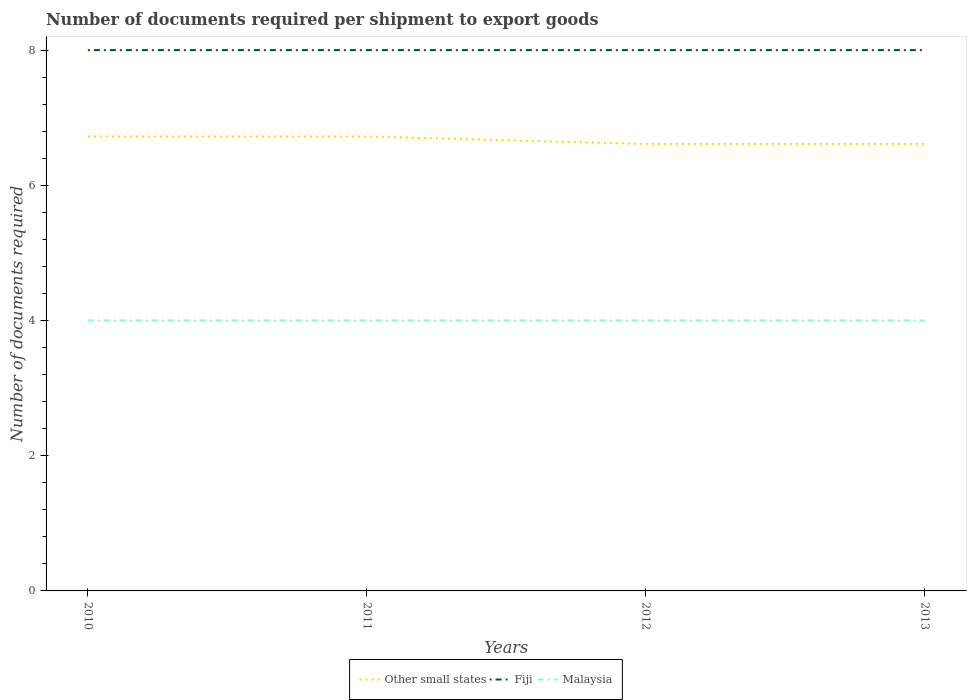Does the line corresponding to Other small states intersect with the line corresponding to Malaysia?
Keep it short and to the point. No. Is the number of lines equal to the number of legend labels?
Keep it short and to the point. Yes. Across all years, what is the maximum number of documents required per shipment to export goods in Malaysia?
Offer a very short reply. 4. What is the total number of documents required per shipment to export goods in Other small states in the graph?
Your answer should be very brief. 0.11. What is the difference between the highest and the second highest number of documents required per shipment to export goods in Malaysia?
Offer a very short reply. 0. What is the difference between the highest and the lowest number of documents required per shipment to export goods in Other small states?
Give a very brief answer. 2. Is the number of documents required per shipment to export goods in Malaysia strictly greater than the number of documents required per shipment to export goods in Other small states over the years?
Provide a succinct answer. Yes. How many lines are there?
Provide a short and direct response. 3. What is the difference between two consecutive major ticks on the Y-axis?
Offer a very short reply. 2. Does the graph contain any zero values?
Offer a very short reply. No. Does the graph contain grids?
Ensure brevity in your answer.  No. How many legend labels are there?
Your response must be concise. 3. How are the legend labels stacked?
Offer a very short reply. Horizontal. What is the title of the graph?
Ensure brevity in your answer.  Number of documents required per shipment to export goods. Does "Kyrgyz Republic" appear as one of the legend labels in the graph?
Your answer should be very brief. No. What is the label or title of the X-axis?
Provide a succinct answer. Years. What is the label or title of the Y-axis?
Make the answer very short. Number of documents required. What is the Number of documents required of Other small states in 2010?
Your answer should be compact. 6.72. What is the Number of documents required of Malaysia in 2010?
Provide a succinct answer. 4. What is the Number of documents required of Other small states in 2011?
Make the answer very short. 6.72. What is the Number of documents required of Fiji in 2011?
Keep it short and to the point. 8. What is the Number of documents required in Malaysia in 2011?
Give a very brief answer. 4. What is the Number of documents required of Other small states in 2012?
Offer a terse response. 6.61. What is the Number of documents required in Malaysia in 2012?
Keep it short and to the point. 4. What is the Number of documents required of Other small states in 2013?
Provide a short and direct response. 6.61. What is the Number of documents required in Fiji in 2013?
Provide a succinct answer. 8. Across all years, what is the maximum Number of documents required in Other small states?
Make the answer very short. 6.72. Across all years, what is the maximum Number of documents required in Malaysia?
Offer a terse response. 4. Across all years, what is the minimum Number of documents required in Other small states?
Give a very brief answer. 6.61. What is the total Number of documents required of Other small states in the graph?
Give a very brief answer. 26.67. What is the total Number of documents required of Fiji in the graph?
Your response must be concise. 32. What is the difference between the Number of documents required of Fiji in 2010 and that in 2011?
Give a very brief answer. 0. What is the difference between the Number of documents required of Malaysia in 2010 and that in 2011?
Your response must be concise. 0. What is the difference between the Number of documents required in Fiji in 2010 and that in 2012?
Give a very brief answer. 0. What is the difference between the Number of documents required of Malaysia in 2010 and that in 2013?
Keep it short and to the point. 0. What is the difference between the Number of documents required in Other small states in 2011 and that in 2012?
Make the answer very short. 0.11. What is the difference between the Number of documents required of Fiji in 2011 and that in 2012?
Make the answer very short. 0. What is the difference between the Number of documents required of Malaysia in 2011 and that in 2012?
Provide a short and direct response. 0. What is the difference between the Number of documents required of Malaysia in 2011 and that in 2013?
Keep it short and to the point. 0. What is the difference between the Number of documents required of Other small states in 2012 and that in 2013?
Provide a succinct answer. 0. What is the difference between the Number of documents required of Malaysia in 2012 and that in 2013?
Ensure brevity in your answer.  0. What is the difference between the Number of documents required in Other small states in 2010 and the Number of documents required in Fiji in 2011?
Make the answer very short. -1.28. What is the difference between the Number of documents required of Other small states in 2010 and the Number of documents required of Malaysia in 2011?
Your response must be concise. 2.72. What is the difference between the Number of documents required of Other small states in 2010 and the Number of documents required of Fiji in 2012?
Ensure brevity in your answer.  -1.28. What is the difference between the Number of documents required of Other small states in 2010 and the Number of documents required of Malaysia in 2012?
Your answer should be compact. 2.72. What is the difference between the Number of documents required in Fiji in 2010 and the Number of documents required in Malaysia in 2012?
Offer a terse response. 4. What is the difference between the Number of documents required in Other small states in 2010 and the Number of documents required in Fiji in 2013?
Offer a very short reply. -1.28. What is the difference between the Number of documents required of Other small states in 2010 and the Number of documents required of Malaysia in 2013?
Keep it short and to the point. 2.72. What is the difference between the Number of documents required of Other small states in 2011 and the Number of documents required of Fiji in 2012?
Provide a short and direct response. -1.28. What is the difference between the Number of documents required of Other small states in 2011 and the Number of documents required of Malaysia in 2012?
Provide a succinct answer. 2.72. What is the difference between the Number of documents required in Fiji in 2011 and the Number of documents required in Malaysia in 2012?
Offer a very short reply. 4. What is the difference between the Number of documents required of Other small states in 2011 and the Number of documents required of Fiji in 2013?
Make the answer very short. -1.28. What is the difference between the Number of documents required of Other small states in 2011 and the Number of documents required of Malaysia in 2013?
Keep it short and to the point. 2.72. What is the difference between the Number of documents required in Fiji in 2011 and the Number of documents required in Malaysia in 2013?
Make the answer very short. 4. What is the difference between the Number of documents required in Other small states in 2012 and the Number of documents required in Fiji in 2013?
Offer a very short reply. -1.39. What is the difference between the Number of documents required of Other small states in 2012 and the Number of documents required of Malaysia in 2013?
Your response must be concise. 2.61. What is the difference between the Number of documents required of Fiji in 2012 and the Number of documents required of Malaysia in 2013?
Ensure brevity in your answer.  4. What is the average Number of documents required in Fiji per year?
Offer a very short reply. 8. What is the average Number of documents required in Malaysia per year?
Ensure brevity in your answer.  4. In the year 2010, what is the difference between the Number of documents required of Other small states and Number of documents required of Fiji?
Offer a very short reply. -1.28. In the year 2010, what is the difference between the Number of documents required of Other small states and Number of documents required of Malaysia?
Your answer should be compact. 2.72. In the year 2010, what is the difference between the Number of documents required of Fiji and Number of documents required of Malaysia?
Your answer should be very brief. 4. In the year 2011, what is the difference between the Number of documents required in Other small states and Number of documents required in Fiji?
Your answer should be very brief. -1.28. In the year 2011, what is the difference between the Number of documents required of Other small states and Number of documents required of Malaysia?
Offer a terse response. 2.72. In the year 2012, what is the difference between the Number of documents required in Other small states and Number of documents required in Fiji?
Offer a very short reply. -1.39. In the year 2012, what is the difference between the Number of documents required of Other small states and Number of documents required of Malaysia?
Your answer should be compact. 2.61. In the year 2012, what is the difference between the Number of documents required in Fiji and Number of documents required in Malaysia?
Ensure brevity in your answer.  4. In the year 2013, what is the difference between the Number of documents required of Other small states and Number of documents required of Fiji?
Your answer should be very brief. -1.39. In the year 2013, what is the difference between the Number of documents required of Other small states and Number of documents required of Malaysia?
Your answer should be very brief. 2.61. In the year 2013, what is the difference between the Number of documents required of Fiji and Number of documents required of Malaysia?
Your answer should be very brief. 4. What is the ratio of the Number of documents required in Other small states in 2010 to that in 2011?
Offer a terse response. 1. What is the ratio of the Number of documents required of Malaysia in 2010 to that in 2011?
Offer a terse response. 1. What is the ratio of the Number of documents required of Other small states in 2010 to that in 2012?
Offer a very short reply. 1.02. What is the ratio of the Number of documents required in Malaysia in 2010 to that in 2012?
Provide a succinct answer. 1. What is the ratio of the Number of documents required in Other small states in 2010 to that in 2013?
Your response must be concise. 1.02. What is the ratio of the Number of documents required of Fiji in 2010 to that in 2013?
Your response must be concise. 1. What is the ratio of the Number of documents required of Other small states in 2011 to that in 2012?
Provide a succinct answer. 1.02. What is the ratio of the Number of documents required in Other small states in 2011 to that in 2013?
Your response must be concise. 1.02. What is the ratio of the Number of documents required in Fiji in 2011 to that in 2013?
Your answer should be very brief. 1. What is the ratio of the Number of documents required in Other small states in 2012 to that in 2013?
Make the answer very short. 1. What is the ratio of the Number of documents required of Fiji in 2012 to that in 2013?
Give a very brief answer. 1. What is the ratio of the Number of documents required of Malaysia in 2012 to that in 2013?
Give a very brief answer. 1. What is the difference between the highest and the second highest Number of documents required of Other small states?
Offer a terse response. 0. What is the difference between the highest and the second highest Number of documents required in Fiji?
Your answer should be compact. 0. What is the difference between the highest and the second highest Number of documents required of Malaysia?
Provide a short and direct response. 0. What is the difference between the highest and the lowest Number of documents required of Other small states?
Provide a short and direct response. 0.11. 